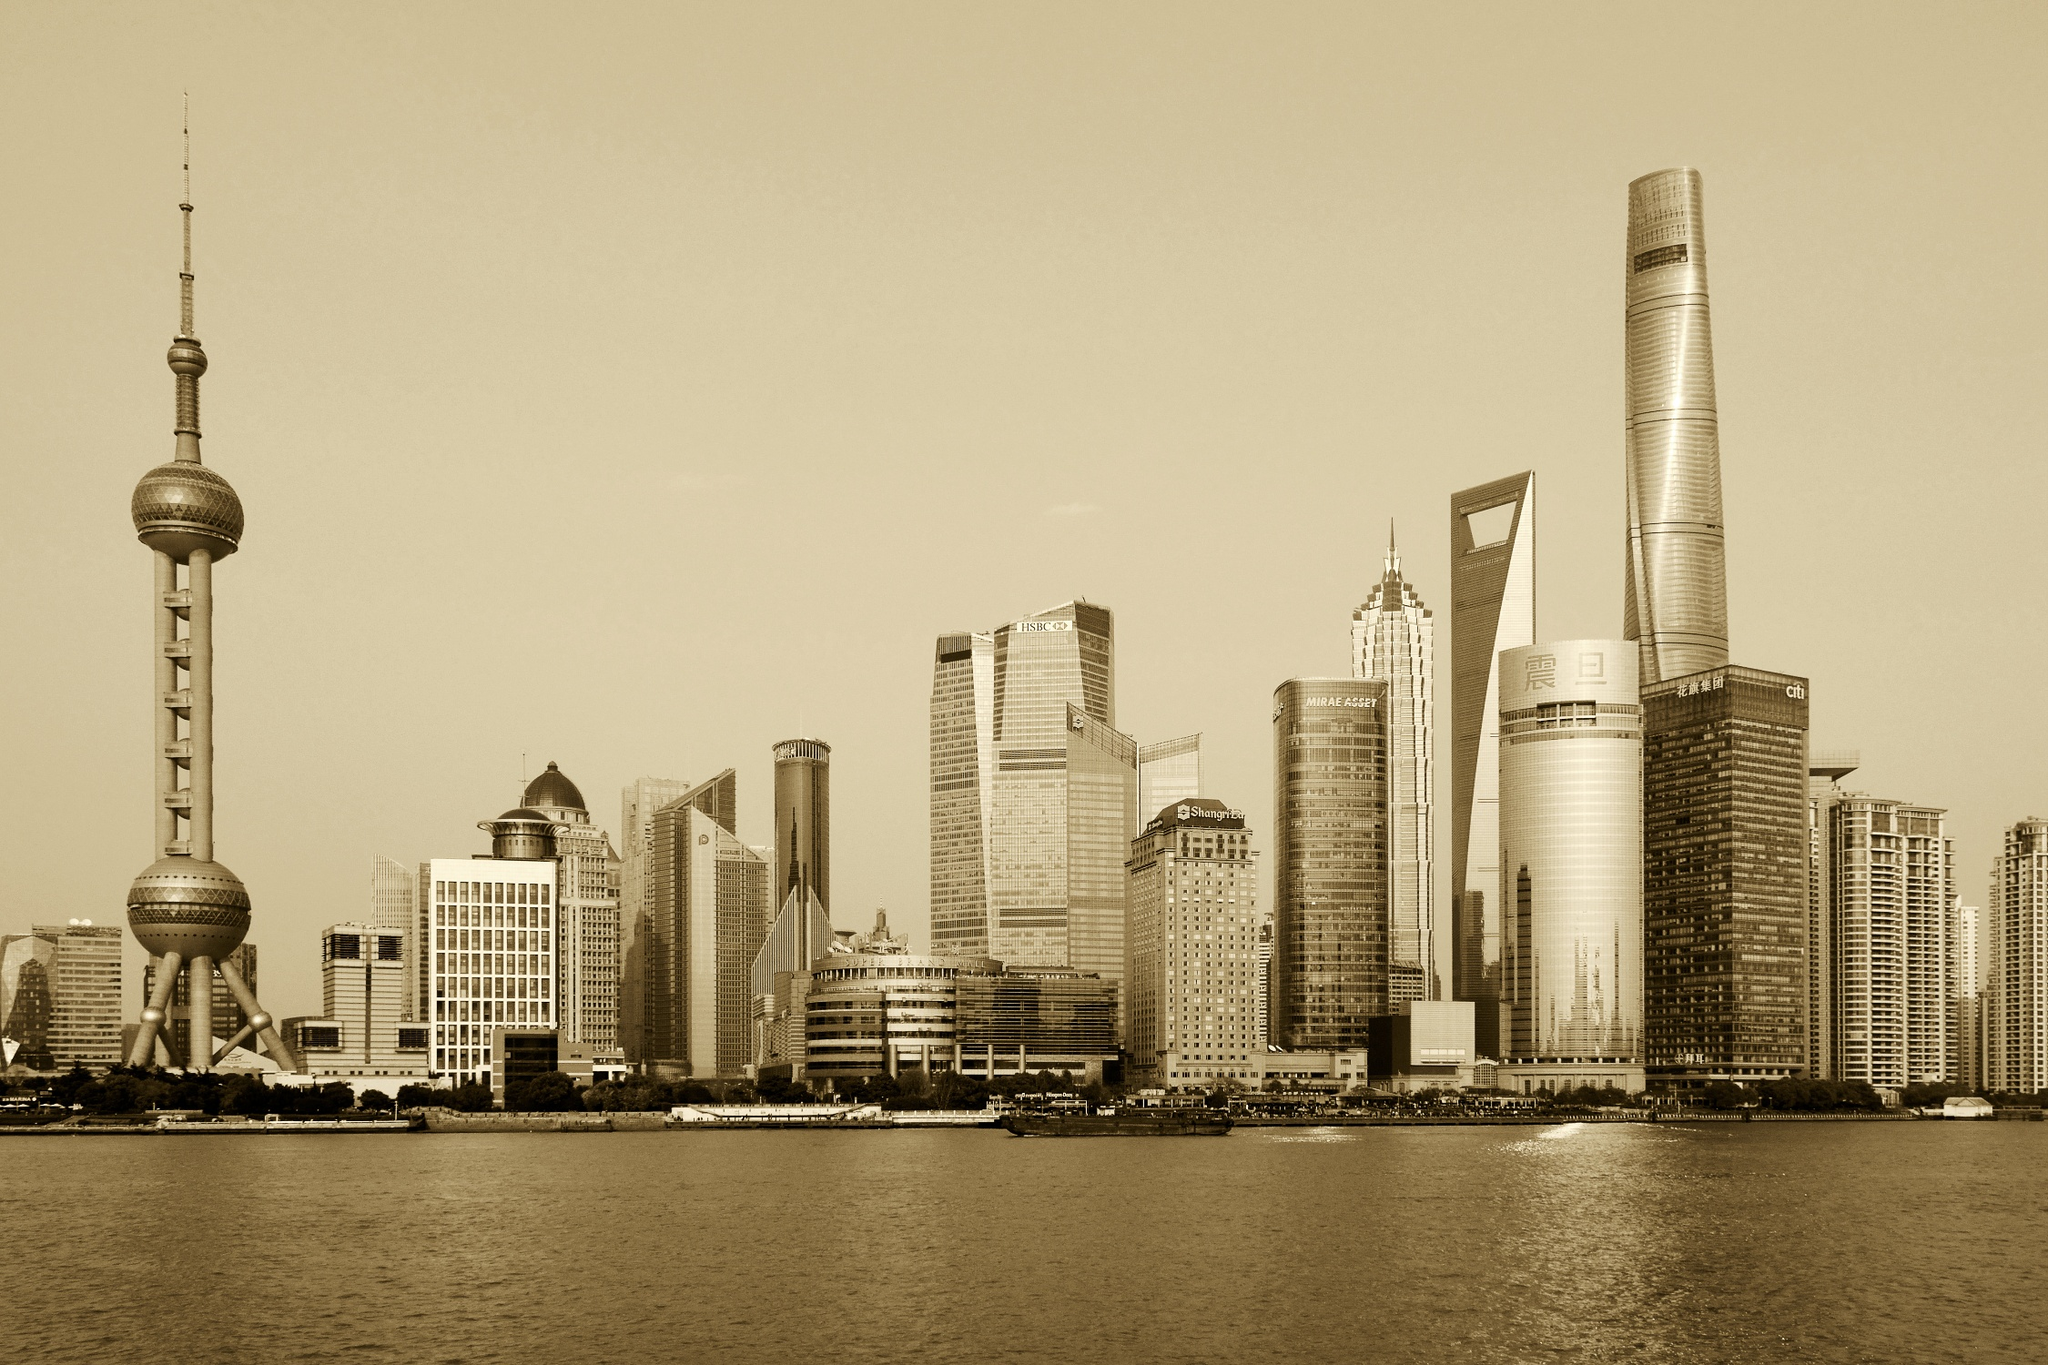Can you describe the main features of this image for me? This image showcases the iconic skyline of Shanghai, as seen from the serene waters of the Huangpu River. The sepia tone of the photograph imparts a classic and timeless feel to this bustling metropolis. Dominating the skyline is the remarkable Oriental Pearl Tower, with its spherical structures at varying heights, adding a distinct touch to the urban landscape. Surrounding it are other towering edifices, such as the Shanghai World Financial Center with its striking bottle opener shape, the elegant Jin Mao Tower with its tiered skyscraper design, and the soaring Shanghai Tower, the tallest structure in the city.

The low-angle perspective of the photo accentuates the lofty stature of these buildings, making them appear to stretch ambitiously towards the clear, expansive sky. The tranquil Huangpu River in the foreground serves as a reflective surface, mirroring the grandeur of the architectural marvels above, thus creating a harmonious symmetry. The image not only captures the physical structures but also reflects the city's dynamic essence and its blend of modernity and tradition. 